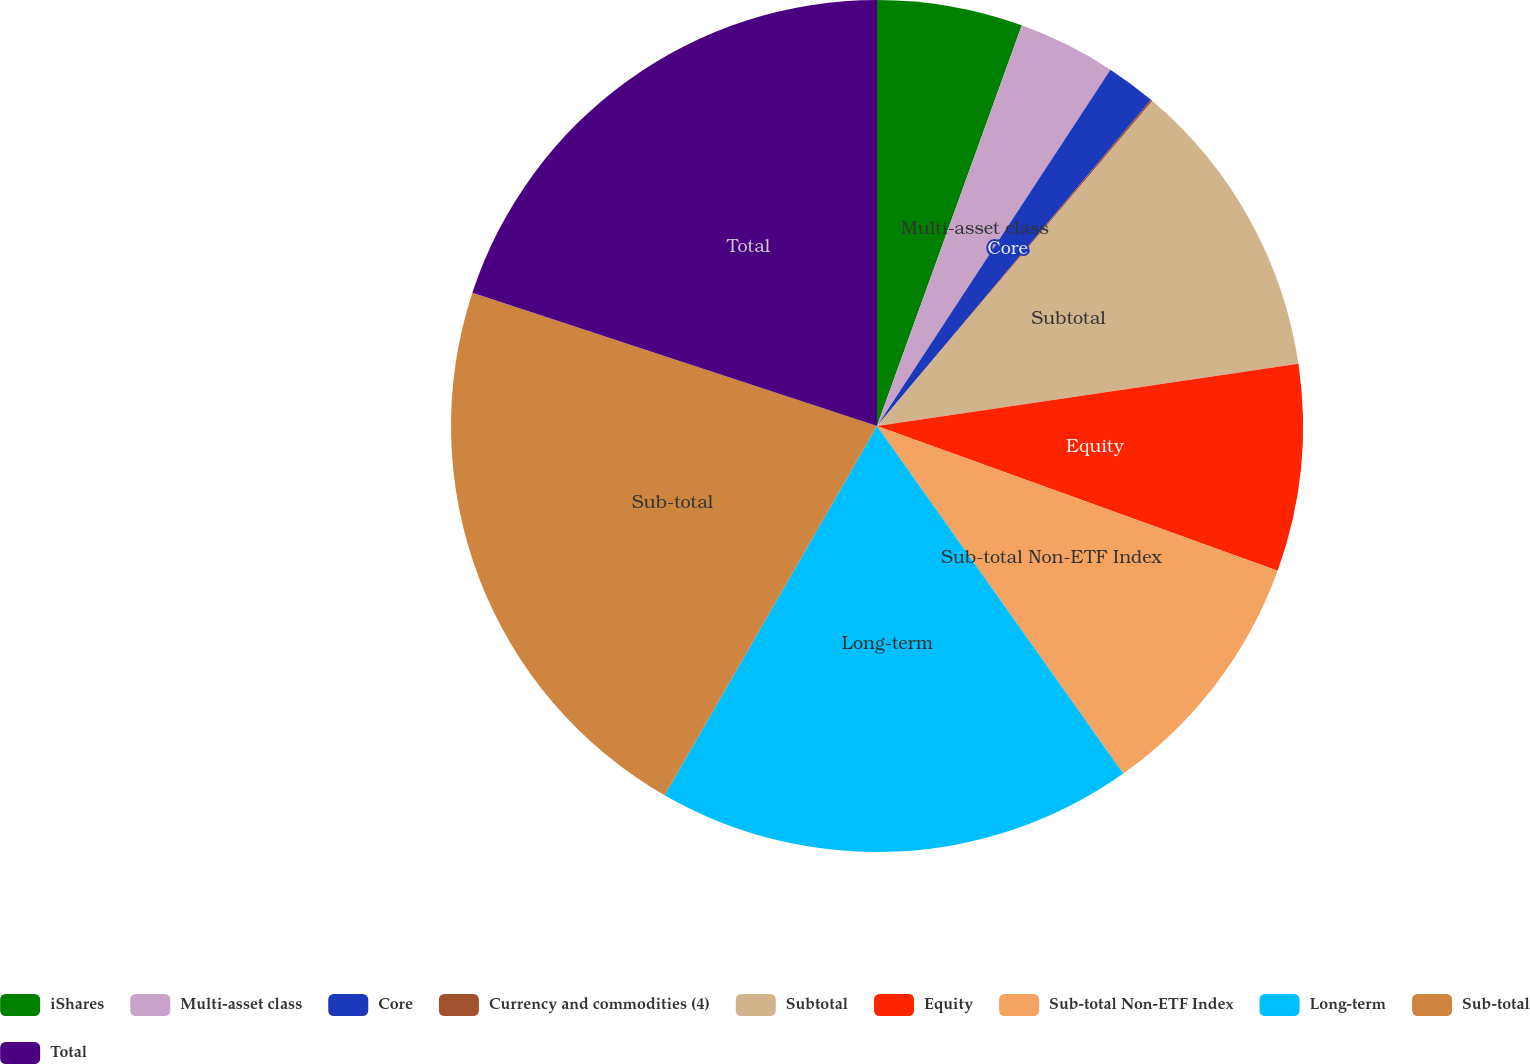Convert chart. <chart><loc_0><loc_0><loc_500><loc_500><pie_chart><fcel>iShares<fcel>Multi-asset class<fcel>Core<fcel>Currency and commodities (4)<fcel>Subtotal<fcel>Equity<fcel>Sub-total Non-ETF Index<fcel>Long-term<fcel>Sub-total<fcel>Total<nl><fcel>5.52%<fcel>3.71%<fcel>1.89%<fcel>0.07%<fcel>11.48%<fcel>7.85%<fcel>9.67%<fcel>18.12%<fcel>21.75%<fcel>19.94%<nl></chart> 